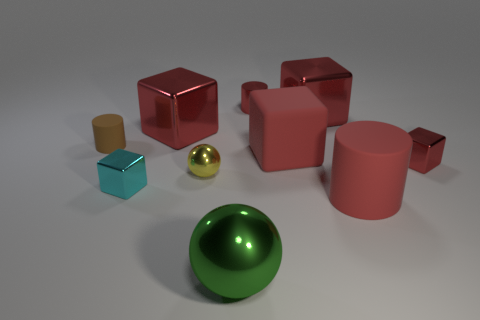How many red blocks must be subtracted to get 1 red blocks? 3 Subtract all blue cylinders. How many red cubes are left? 4 Subtract all brown blocks. Subtract all purple cylinders. How many blocks are left? 5 Subtract all balls. How many objects are left? 8 Add 8 big cylinders. How many big cylinders are left? 9 Add 4 gray things. How many gray things exist? 4 Subtract 2 red cylinders. How many objects are left? 8 Subtract all green metal spheres. Subtract all yellow objects. How many objects are left? 8 